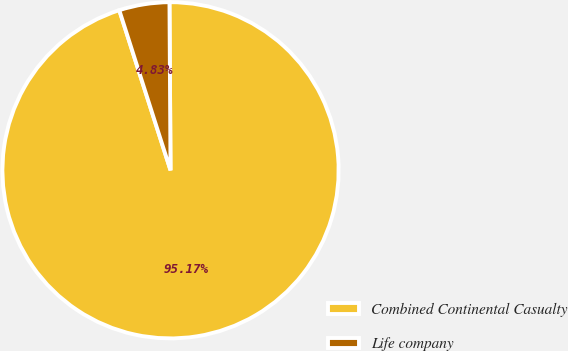Convert chart. <chart><loc_0><loc_0><loc_500><loc_500><pie_chart><fcel>Combined Continental Casualty<fcel>Life company<nl><fcel>95.17%<fcel>4.83%<nl></chart> 